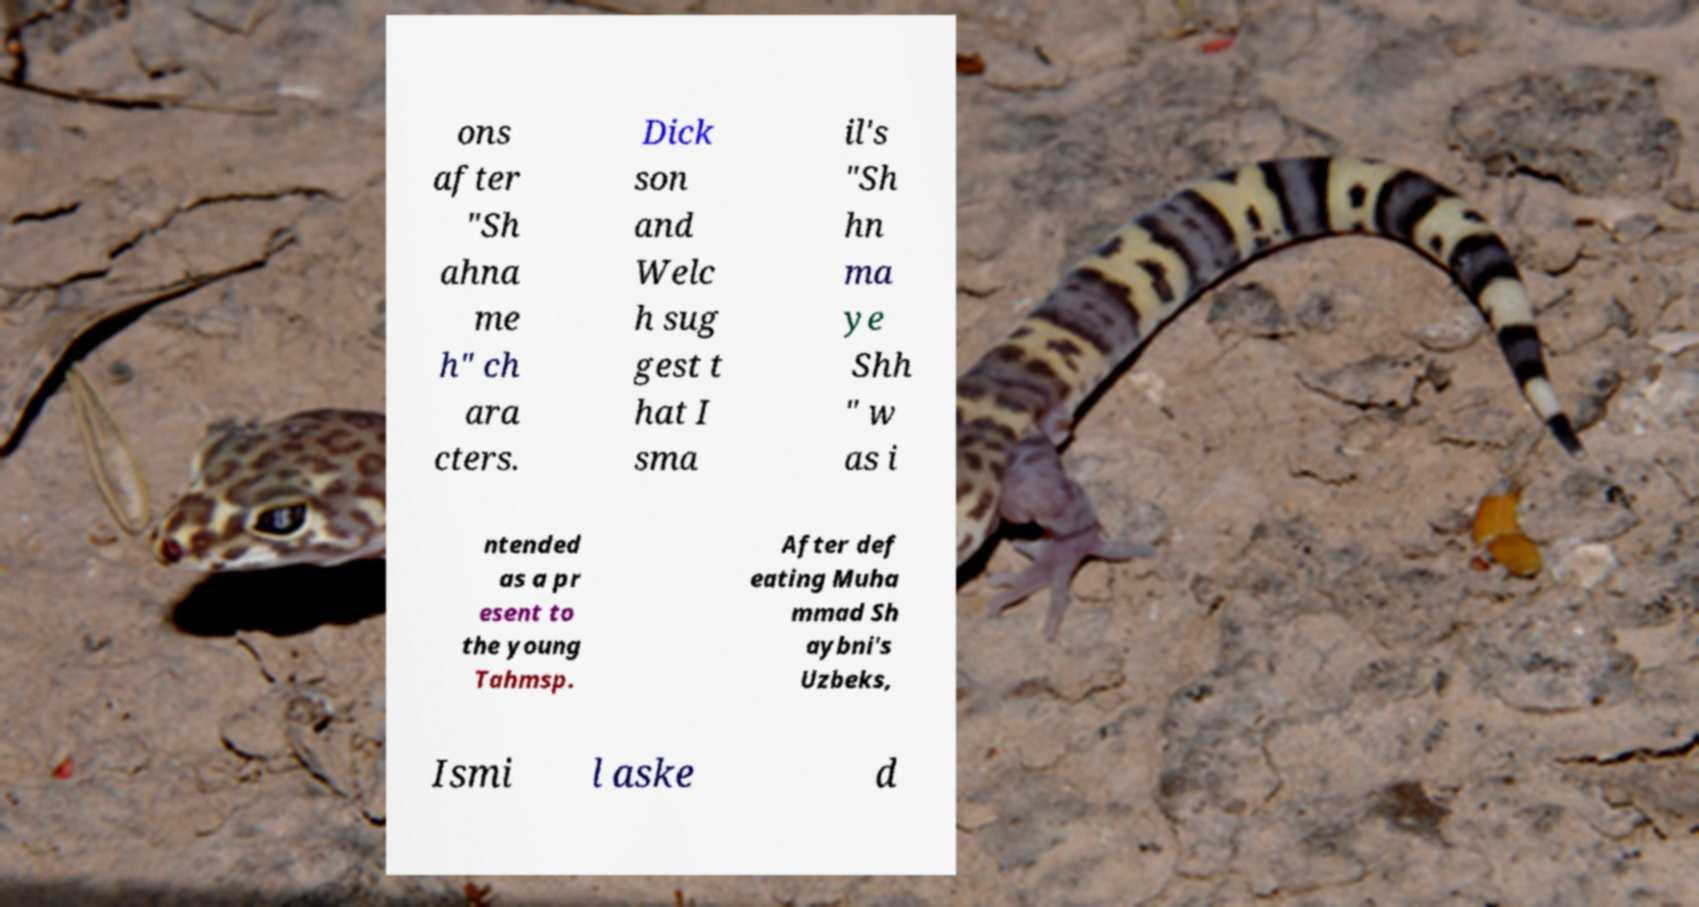What messages or text are displayed in this image? I need them in a readable, typed format. ons after "Sh ahna me h" ch ara cters. Dick son and Welc h sug gest t hat I sma il's "Sh hn ma ye Shh " w as i ntended as a pr esent to the young Tahmsp. After def eating Muha mmad Sh aybni's Uzbeks, Ismi l aske d 